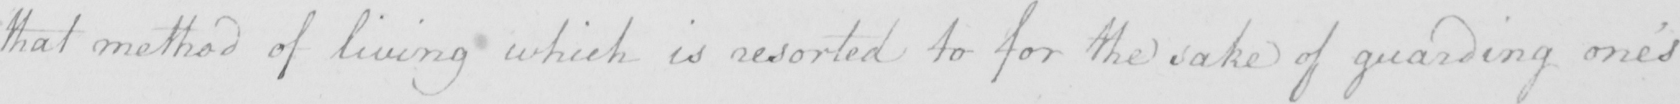Can you read and transcribe this handwriting? that method of living which is resorted to for the sake of guarding one ' s 